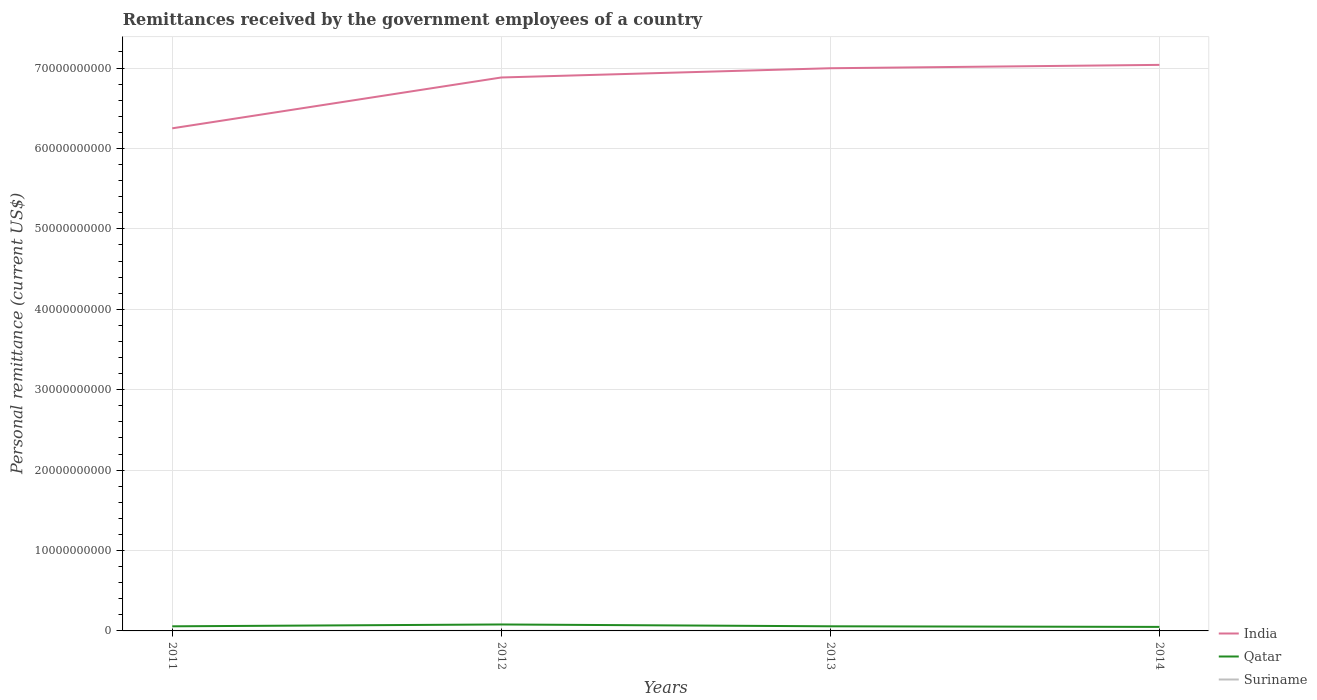Does the line corresponding to Suriname intersect with the line corresponding to Qatar?
Your answer should be very brief. No. Is the number of lines equal to the number of legend labels?
Your answer should be very brief. Yes. Across all years, what is the maximum remittances received by the government employees in Qatar?
Offer a very short reply. 4.99e+08. In which year was the remittances received by the government employees in Qatar maximum?
Provide a succinct answer. 2014. What is the total remittances received by the government employees in Suriname in the graph?
Give a very brief answer. -3.10e+06. What is the difference between the highest and the second highest remittances received by the government employees in Suriname?
Offer a very short reply. 4.94e+06. Is the remittances received by the government employees in Qatar strictly greater than the remittances received by the government employees in Suriname over the years?
Your response must be concise. No. How many lines are there?
Ensure brevity in your answer.  3. Does the graph contain any zero values?
Keep it short and to the point. No. Does the graph contain grids?
Offer a very short reply. Yes. Where does the legend appear in the graph?
Offer a very short reply. Bottom right. How many legend labels are there?
Provide a succinct answer. 3. How are the legend labels stacked?
Your response must be concise. Vertical. What is the title of the graph?
Your answer should be very brief. Remittances received by the government employees of a country. Does "OECD members" appear as one of the legend labels in the graph?
Your answer should be very brief. No. What is the label or title of the X-axis?
Your answer should be compact. Years. What is the label or title of the Y-axis?
Keep it short and to the point. Personal remittance (current US$). What is the Personal remittance (current US$) in India in 2011?
Keep it short and to the point. 6.25e+1. What is the Personal remittance (current US$) in Qatar in 2011?
Offer a very short reply. 5.74e+08. What is the Personal remittance (current US$) in Suriname in 2011?
Your answer should be compact. 3.89e+06. What is the Personal remittance (current US$) in India in 2012?
Give a very brief answer. 6.88e+1. What is the Personal remittance (current US$) in Qatar in 2012?
Keep it short and to the point. 8.03e+08. What is the Personal remittance (current US$) in Suriname in 2012?
Keep it short and to the point. 8.06e+06. What is the Personal remittance (current US$) in India in 2013?
Offer a terse response. 7.00e+1. What is the Personal remittance (current US$) of Qatar in 2013?
Provide a succinct answer. 5.74e+08. What is the Personal remittance (current US$) in Suriname in 2013?
Provide a succinct answer. 6.99e+06. What is the Personal remittance (current US$) of India in 2014?
Provide a short and direct response. 7.04e+1. What is the Personal remittance (current US$) in Qatar in 2014?
Ensure brevity in your answer.  4.99e+08. What is the Personal remittance (current US$) of Suriname in 2014?
Ensure brevity in your answer.  8.83e+06. Across all years, what is the maximum Personal remittance (current US$) of India?
Your answer should be compact. 7.04e+1. Across all years, what is the maximum Personal remittance (current US$) in Qatar?
Make the answer very short. 8.03e+08. Across all years, what is the maximum Personal remittance (current US$) in Suriname?
Offer a terse response. 8.83e+06. Across all years, what is the minimum Personal remittance (current US$) in India?
Your response must be concise. 6.25e+1. Across all years, what is the minimum Personal remittance (current US$) of Qatar?
Your answer should be compact. 4.99e+08. Across all years, what is the minimum Personal remittance (current US$) of Suriname?
Your answer should be compact. 3.89e+06. What is the total Personal remittance (current US$) of India in the graph?
Your answer should be very brief. 2.72e+11. What is the total Personal remittance (current US$) of Qatar in the graph?
Your answer should be compact. 2.45e+09. What is the total Personal remittance (current US$) of Suriname in the graph?
Your response must be concise. 2.78e+07. What is the difference between the Personal remittance (current US$) of India in 2011 and that in 2012?
Offer a terse response. -6.32e+09. What is the difference between the Personal remittance (current US$) in Qatar in 2011 and that in 2012?
Offer a very short reply. -2.30e+08. What is the difference between the Personal remittance (current US$) of Suriname in 2011 and that in 2012?
Your answer should be compact. -4.16e+06. What is the difference between the Personal remittance (current US$) in India in 2011 and that in 2013?
Provide a short and direct response. -7.47e+09. What is the difference between the Personal remittance (current US$) in Qatar in 2011 and that in 2013?
Offer a terse response. -7.69e+05. What is the difference between the Personal remittance (current US$) in Suriname in 2011 and that in 2013?
Give a very brief answer. -3.10e+06. What is the difference between the Personal remittance (current US$) of India in 2011 and that in 2014?
Offer a very short reply. -7.89e+09. What is the difference between the Personal remittance (current US$) of Qatar in 2011 and that in 2014?
Make the answer very short. 7.50e+07. What is the difference between the Personal remittance (current US$) in Suriname in 2011 and that in 2014?
Keep it short and to the point. -4.94e+06. What is the difference between the Personal remittance (current US$) in India in 2012 and that in 2013?
Offer a very short reply. -1.15e+09. What is the difference between the Personal remittance (current US$) in Qatar in 2012 and that in 2013?
Provide a succinct answer. 2.29e+08. What is the difference between the Personal remittance (current US$) in Suriname in 2012 and that in 2013?
Provide a short and direct response. 1.06e+06. What is the difference between the Personal remittance (current US$) of India in 2012 and that in 2014?
Your answer should be very brief. -1.57e+09. What is the difference between the Personal remittance (current US$) of Qatar in 2012 and that in 2014?
Your response must be concise. 3.05e+08. What is the difference between the Personal remittance (current US$) of Suriname in 2012 and that in 2014?
Provide a succinct answer. -7.76e+05. What is the difference between the Personal remittance (current US$) in India in 2013 and that in 2014?
Ensure brevity in your answer.  -4.18e+08. What is the difference between the Personal remittance (current US$) in Qatar in 2013 and that in 2014?
Offer a very short reply. 7.58e+07. What is the difference between the Personal remittance (current US$) of Suriname in 2013 and that in 2014?
Keep it short and to the point. -1.84e+06. What is the difference between the Personal remittance (current US$) in India in 2011 and the Personal remittance (current US$) in Qatar in 2012?
Keep it short and to the point. 6.17e+1. What is the difference between the Personal remittance (current US$) of India in 2011 and the Personal remittance (current US$) of Suriname in 2012?
Give a very brief answer. 6.25e+1. What is the difference between the Personal remittance (current US$) in Qatar in 2011 and the Personal remittance (current US$) in Suriname in 2012?
Your answer should be compact. 5.66e+08. What is the difference between the Personal remittance (current US$) of India in 2011 and the Personal remittance (current US$) of Qatar in 2013?
Your response must be concise. 6.19e+1. What is the difference between the Personal remittance (current US$) in India in 2011 and the Personal remittance (current US$) in Suriname in 2013?
Provide a short and direct response. 6.25e+1. What is the difference between the Personal remittance (current US$) of Qatar in 2011 and the Personal remittance (current US$) of Suriname in 2013?
Offer a terse response. 5.67e+08. What is the difference between the Personal remittance (current US$) of India in 2011 and the Personal remittance (current US$) of Qatar in 2014?
Offer a terse response. 6.20e+1. What is the difference between the Personal remittance (current US$) of India in 2011 and the Personal remittance (current US$) of Suriname in 2014?
Offer a terse response. 6.25e+1. What is the difference between the Personal remittance (current US$) of Qatar in 2011 and the Personal remittance (current US$) of Suriname in 2014?
Offer a terse response. 5.65e+08. What is the difference between the Personal remittance (current US$) of India in 2012 and the Personal remittance (current US$) of Qatar in 2013?
Keep it short and to the point. 6.82e+1. What is the difference between the Personal remittance (current US$) of India in 2012 and the Personal remittance (current US$) of Suriname in 2013?
Your response must be concise. 6.88e+1. What is the difference between the Personal remittance (current US$) of Qatar in 2012 and the Personal remittance (current US$) of Suriname in 2013?
Make the answer very short. 7.96e+08. What is the difference between the Personal remittance (current US$) of India in 2012 and the Personal remittance (current US$) of Qatar in 2014?
Provide a short and direct response. 6.83e+1. What is the difference between the Personal remittance (current US$) of India in 2012 and the Personal remittance (current US$) of Suriname in 2014?
Make the answer very short. 6.88e+1. What is the difference between the Personal remittance (current US$) in Qatar in 2012 and the Personal remittance (current US$) in Suriname in 2014?
Keep it short and to the point. 7.94e+08. What is the difference between the Personal remittance (current US$) in India in 2013 and the Personal remittance (current US$) in Qatar in 2014?
Your answer should be very brief. 6.95e+1. What is the difference between the Personal remittance (current US$) in India in 2013 and the Personal remittance (current US$) in Suriname in 2014?
Offer a terse response. 7.00e+1. What is the difference between the Personal remittance (current US$) in Qatar in 2013 and the Personal remittance (current US$) in Suriname in 2014?
Keep it short and to the point. 5.66e+08. What is the average Personal remittance (current US$) of India per year?
Provide a succinct answer. 6.79e+1. What is the average Personal remittance (current US$) in Qatar per year?
Make the answer very short. 6.12e+08. What is the average Personal remittance (current US$) of Suriname per year?
Offer a terse response. 6.94e+06. In the year 2011, what is the difference between the Personal remittance (current US$) in India and Personal remittance (current US$) in Qatar?
Provide a succinct answer. 6.19e+1. In the year 2011, what is the difference between the Personal remittance (current US$) in India and Personal remittance (current US$) in Suriname?
Provide a short and direct response. 6.25e+1. In the year 2011, what is the difference between the Personal remittance (current US$) in Qatar and Personal remittance (current US$) in Suriname?
Your answer should be compact. 5.70e+08. In the year 2012, what is the difference between the Personal remittance (current US$) in India and Personal remittance (current US$) in Qatar?
Ensure brevity in your answer.  6.80e+1. In the year 2012, what is the difference between the Personal remittance (current US$) of India and Personal remittance (current US$) of Suriname?
Make the answer very short. 6.88e+1. In the year 2012, what is the difference between the Personal remittance (current US$) in Qatar and Personal remittance (current US$) in Suriname?
Make the answer very short. 7.95e+08. In the year 2013, what is the difference between the Personal remittance (current US$) in India and Personal remittance (current US$) in Qatar?
Offer a terse response. 6.94e+1. In the year 2013, what is the difference between the Personal remittance (current US$) of India and Personal remittance (current US$) of Suriname?
Provide a short and direct response. 7.00e+1. In the year 2013, what is the difference between the Personal remittance (current US$) in Qatar and Personal remittance (current US$) in Suriname?
Your answer should be very brief. 5.67e+08. In the year 2014, what is the difference between the Personal remittance (current US$) of India and Personal remittance (current US$) of Qatar?
Provide a succinct answer. 6.99e+1. In the year 2014, what is the difference between the Personal remittance (current US$) in India and Personal remittance (current US$) in Suriname?
Give a very brief answer. 7.04e+1. In the year 2014, what is the difference between the Personal remittance (current US$) in Qatar and Personal remittance (current US$) in Suriname?
Ensure brevity in your answer.  4.90e+08. What is the ratio of the Personal remittance (current US$) in India in 2011 to that in 2012?
Offer a terse response. 0.91. What is the ratio of the Personal remittance (current US$) in Qatar in 2011 to that in 2012?
Offer a terse response. 0.71. What is the ratio of the Personal remittance (current US$) in Suriname in 2011 to that in 2012?
Your answer should be very brief. 0.48. What is the ratio of the Personal remittance (current US$) of India in 2011 to that in 2013?
Offer a terse response. 0.89. What is the ratio of the Personal remittance (current US$) in Qatar in 2011 to that in 2013?
Your response must be concise. 1. What is the ratio of the Personal remittance (current US$) of Suriname in 2011 to that in 2013?
Make the answer very short. 0.56. What is the ratio of the Personal remittance (current US$) in India in 2011 to that in 2014?
Offer a very short reply. 0.89. What is the ratio of the Personal remittance (current US$) of Qatar in 2011 to that in 2014?
Offer a terse response. 1.15. What is the ratio of the Personal remittance (current US$) in Suriname in 2011 to that in 2014?
Keep it short and to the point. 0.44. What is the ratio of the Personal remittance (current US$) of India in 2012 to that in 2013?
Give a very brief answer. 0.98. What is the ratio of the Personal remittance (current US$) in Qatar in 2012 to that in 2013?
Your response must be concise. 1.4. What is the ratio of the Personal remittance (current US$) in Suriname in 2012 to that in 2013?
Offer a very short reply. 1.15. What is the ratio of the Personal remittance (current US$) of India in 2012 to that in 2014?
Keep it short and to the point. 0.98. What is the ratio of the Personal remittance (current US$) in Qatar in 2012 to that in 2014?
Give a very brief answer. 1.61. What is the ratio of the Personal remittance (current US$) of Suriname in 2012 to that in 2014?
Offer a terse response. 0.91. What is the ratio of the Personal remittance (current US$) of Qatar in 2013 to that in 2014?
Your answer should be very brief. 1.15. What is the ratio of the Personal remittance (current US$) in Suriname in 2013 to that in 2014?
Offer a very short reply. 0.79. What is the difference between the highest and the second highest Personal remittance (current US$) of India?
Your response must be concise. 4.18e+08. What is the difference between the highest and the second highest Personal remittance (current US$) in Qatar?
Your response must be concise. 2.29e+08. What is the difference between the highest and the second highest Personal remittance (current US$) of Suriname?
Keep it short and to the point. 7.76e+05. What is the difference between the highest and the lowest Personal remittance (current US$) of India?
Provide a succinct answer. 7.89e+09. What is the difference between the highest and the lowest Personal remittance (current US$) in Qatar?
Keep it short and to the point. 3.05e+08. What is the difference between the highest and the lowest Personal remittance (current US$) of Suriname?
Provide a succinct answer. 4.94e+06. 